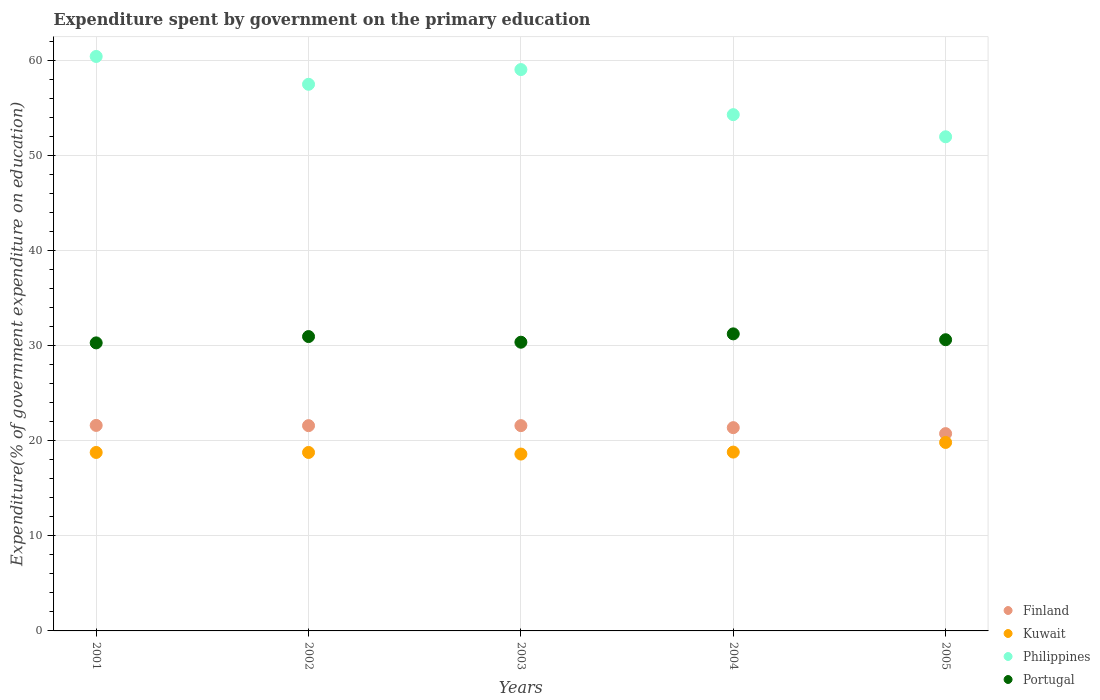What is the expenditure spent by government on the primary education in Kuwait in 2002?
Give a very brief answer. 18.78. Across all years, what is the maximum expenditure spent by government on the primary education in Kuwait?
Ensure brevity in your answer.  19.83. Across all years, what is the minimum expenditure spent by government on the primary education in Philippines?
Provide a succinct answer. 51.99. In which year was the expenditure spent by government on the primary education in Kuwait maximum?
Provide a succinct answer. 2005. What is the total expenditure spent by government on the primary education in Portugal in the graph?
Your answer should be compact. 153.56. What is the difference between the expenditure spent by government on the primary education in Portugal in 2002 and that in 2003?
Your answer should be compact. 0.59. What is the difference between the expenditure spent by government on the primary education in Philippines in 2005 and the expenditure spent by government on the primary education in Portugal in 2001?
Give a very brief answer. 21.69. What is the average expenditure spent by government on the primary education in Portugal per year?
Your answer should be compact. 30.71. In the year 2001, what is the difference between the expenditure spent by government on the primary education in Kuwait and expenditure spent by government on the primary education in Philippines?
Offer a terse response. -41.67. In how many years, is the expenditure spent by government on the primary education in Kuwait greater than 14 %?
Offer a very short reply. 5. What is the ratio of the expenditure spent by government on the primary education in Philippines in 2004 to that in 2005?
Offer a terse response. 1.04. Is the expenditure spent by government on the primary education in Kuwait in 2002 less than that in 2005?
Provide a short and direct response. Yes. Is the difference between the expenditure spent by government on the primary education in Kuwait in 2003 and 2004 greater than the difference between the expenditure spent by government on the primary education in Philippines in 2003 and 2004?
Ensure brevity in your answer.  No. What is the difference between the highest and the second highest expenditure spent by government on the primary education in Philippines?
Keep it short and to the point. 1.38. What is the difference between the highest and the lowest expenditure spent by government on the primary education in Finland?
Provide a short and direct response. 0.86. Is the sum of the expenditure spent by government on the primary education in Portugal in 2002 and 2004 greater than the maximum expenditure spent by government on the primary education in Finland across all years?
Keep it short and to the point. Yes. Is it the case that in every year, the sum of the expenditure spent by government on the primary education in Philippines and expenditure spent by government on the primary education in Finland  is greater than the sum of expenditure spent by government on the primary education in Kuwait and expenditure spent by government on the primary education in Portugal?
Give a very brief answer. No. How many dotlines are there?
Ensure brevity in your answer.  4. Are the values on the major ticks of Y-axis written in scientific E-notation?
Your answer should be very brief. No. Does the graph contain grids?
Provide a succinct answer. Yes. How many legend labels are there?
Your response must be concise. 4. How are the legend labels stacked?
Make the answer very short. Vertical. What is the title of the graph?
Provide a short and direct response. Expenditure spent by government on the primary education. What is the label or title of the Y-axis?
Offer a very short reply. Expenditure(% of government expenditure on education). What is the Expenditure(% of government expenditure on education) in Finland in 2001?
Provide a short and direct response. 21.62. What is the Expenditure(% of government expenditure on education) of Kuwait in 2001?
Give a very brief answer. 18.78. What is the Expenditure(% of government expenditure on education) in Philippines in 2001?
Provide a short and direct response. 60.45. What is the Expenditure(% of government expenditure on education) of Portugal in 2001?
Keep it short and to the point. 30.31. What is the Expenditure(% of government expenditure on education) of Finland in 2002?
Your answer should be very brief. 21.6. What is the Expenditure(% of government expenditure on education) in Kuwait in 2002?
Make the answer very short. 18.78. What is the Expenditure(% of government expenditure on education) in Philippines in 2002?
Provide a succinct answer. 57.52. What is the Expenditure(% of government expenditure on education) of Portugal in 2002?
Your response must be concise. 30.97. What is the Expenditure(% of government expenditure on education) in Finland in 2003?
Provide a short and direct response. 21.6. What is the Expenditure(% of government expenditure on education) of Kuwait in 2003?
Offer a very short reply. 18.61. What is the Expenditure(% of government expenditure on education) in Philippines in 2003?
Provide a succinct answer. 59.07. What is the Expenditure(% of government expenditure on education) of Portugal in 2003?
Provide a succinct answer. 30.38. What is the Expenditure(% of government expenditure on education) in Finland in 2004?
Your response must be concise. 21.39. What is the Expenditure(% of government expenditure on education) of Kuwait in 2004?
Offer a terse response. 18.82. What is the Expenditure(% of government expenditure on education) in Philippines in 2004?
Keep it short and to the point. 54.32. What is the Expenditure(% of government expenditure on education) in Portugal in 2004?
Your response must be concise. 31.26. What is the Expenditure(% of government expenditure on education) of Finland in 2005?
Your answer should be compact. 20.76. What is the Expenditure(% of government expenditure on education) in Kuwait in 2005?
Your response must be concise. 19.83. What is the Expenditure(% of government expenditure on education) of Philippines in 2005?
Offer a terse response. 51.99. What is the Expenditure(% of government expenditure on education) in Portugal in 2005?
Keep it short and to the point. 30.64. Across all years, what is the maximum Expenditure(% of government expenditure on education) in Finland?
Provide a succinct answer. 21.62. Across all years, what is the maximum Expenditure(% of government expenditure on education) in Kuwait?
Offer a terse response. 19.83. Across all years, what is the maximum Expenditure(% of government expenditure on education) of Philippines?
Your answer should be very brief. 60.45. Across all years, what is the maximum Expenditure(% of government expenditure on education) of Portugal?
Offer a very short reply. 31.26. Across all years, what is the minimum Expenditure(% of government expenditure on education) of Finland?
Provide a short and direct response. 20.76. Across all years, what is the minimum Expenditure(% of government expenditure on education) in Kuwait?
Ensure brevity in your answer.  18.61. Across all years, what is the minimum Expenditure(% of government expenditure on education) in Philippines?
Your answer should be very brief. 51.99. Across all years, what is the minimum Expenditure(% of government expenditure on education) of Portugal?
Provide a succinct answer. 30.31. What is the total Expenditure(% of government expenditure on education) in Finland in the graph?
Ensure brevity in your answer.  106.97. What is the total Expenditure(% of government expenditure on education) in Kuwait in the graph?
Provide a succinct answer. 94.81. What is the total Expenditure(% of government expenditure on education) in Philippines in the graph?
Your answer should be very brief. 283.35. What is the total Expenditure(% of government expenditure on education) in Portugal in the graph?
Your answer should be very brief. 153.56. What is the difference between the Expenditure(% of government expenditure on education) in Finland in 2001 and that in 2002?
Offer a terse response. 0.03. What is the difference between the Expenditure(% of government expenditure on education) in Kuwait in 2001 and that in 2002?
Give a very brief answer. 0. What is the difference between the Expenditure(% of government expenditure on education) in Philippines in 2001 and that in 2002?
Keep it short and to the point. 2.93. What is the difference between the Expenditure(% of government expenditure on education) in Portugal in 2001 and that in 2002?
Provide a succinct answer. -0.66. What is the difference between the Expenditure(% of government expenditure on education) in Finland in 2001 and that in 2003?
Provide a short and direct response. 0.02. What is the difference between the Expenditure(% of government expenditure on education) in Kuwait in 2001 and that in 2003?
Make the answer very short. 0.17. What is the difference between the Expenditure(% of government expenditure on education) in Philippines in 2001 and that in 2003?
Make the answer very short. 1.38. What is the difference between the Expenditure(% of government expenditure on education) of Portugal in 2001 and that in 2003?
Your answer should be compact. -0.07. What is the difference between the Expenditure(% of government expenditure on education) in Finland in 2001 and that in 2004?
Your answer should be very brief. 0.24. What is the difference between the Expenditure(% of government expenditure on education) in Kuwait in 2001 and that in 2004?
Your response must be concise. -0.04. What is the difference between the Expenditure(% of government expenditure on education) of Philippines in 2001 and that in 2004?
Give a very brief answer. 6.12. What is the difference between the Expenditure(% of government expenditure on education) in Portugal in 2001 and that in 2004?
Make the answer very short. -0.95. What is the difference between the Expenditure(% of government expenditure on education) of Finland in 2001 and that in 2005?
Your response must be concise. 0.86. What is the difference between the Expenditure(% of government expenditure on education) in Kuwait in 2001 and that in 2005?
Keep it short and to the point. -1.05. What is the difference between the Expenditure(% of government expenditure on education) of Philippines in 2001 and that in 2005?
Provide a succinct answer. 8.45. What is the difference between the Expenditure(% of government expenditure on education) of Portugal in 2001 and that in 2005?
Provide a succinct answer. -0.33. What is the difference between the Expenditure(% of government expenditure on education) of Finland in 2002 and that in 2003?
Keep it short and to the point. -0. What is the difference between the Expenditure(% of government expenditure on education) in Kuwait in 2002 and that in 2003?
Your answer should be compact. 0.17. What is the difference between the Expenditure(% of government expenditure on education) in Philippines in 2002 and that in 2003?
Your answer should be compact. -1.55. What is the difference between the Expenditure(% of government expenditure on education) in Portugal in 2002 and that in 2003?
Offer a very short reply. 0.59. What is the difference between the Expenditure(% of government expenditure on education) in Finland in 2002 and that in 2004?
Ensure brevity in your answer.  0.21. What is the difference between the Expenditure(% of government expenditure on education) in Kuwait in 2002 and that in 2004?
Ensure brevity in your answer.  -0.04. What is the difference between the Expenditure(% of government expenditure on education) in Philippines in 2002 and that in 2004?
Provide a succinct answer. 3.2. What is the difference between the Expenditure(% of government expenditure on education) of Portugal in 2002 and that in 2004?
Ensure brevity in your answer.  -0.28. What is the difference between the Expenditure(% of government expenditure on education) of Finland in 2002 and that in 2005?
Provide a succinct answer. 0.84. What is the difference between the Expenditure(% of government expenditure on education) of Kuwait in 2002 and that in 2005?
Offer a terse response. -1.05. What is the difference between the Expenditure(% of government expenditure on education) in Philippines in 2002 and that in 2005?
Your answer should be very brief. 5.52. What is the difference between the Expenditure(% of government expenditure on education) of Portugal in 2002 and that in 2005?
Offer a terse response. 0.33. What is the difference between the Expenditure(% of government expenditure on education) in Finland in 2003 and that in 2004?
Provide a short and direct response. 0.21. What is the difference between the Expenditure(% of government expenditure on education) in Kuwait in 2003 and that in 2004?
Keep it short and to the point. -0.21. What is the difference between the Expenditure(% of government expenditure on education) in Philippines in 2003 and that in 2004?
Offer a very short reply. 4.74. What is the difference between the Expenditure(% of government expenditure on education) in Portugal in 2003 and that in 2004?
Provide a succinct answer. -0.88. What is the difference between the Expenditure(% of government expenditure on education) of Finland in 2003 and that in 2005?
Make the answer very short. 0.84. What is the difference between the Expenditure(% of government expenditure on education) in Kuwait in 2003 and that in 2005?
Your answer should be very brief. -1.22. What is the difference between the Expenditure(% of government expenditure on education) of Philippines in 2003 and that in 2005?
Offer a very short reply. 7.07. What is the difference between the Expenditure(% of government expenditure on education) in Portugal in 2003 and that in 2005?
Make the answer very short. -0.26. What is the difference between the Expenditure(% of government expenditure on education) in Finland in 2004 and that in 2005?
Ensure brevity in your answer.  0.63. What is the difference between the Expenditure(% of government expenditure on education) of Kuwait in 2004 and that in 2005?
Provide a short and direct response. -1.01. What is the difference between the Expenditure(% of government expenditure on education) of Philippines in 2004 and that in 2005?
Your response must be concise. 2.33. What is the difference between the Expenditure(% of government expenditure on education) of Portugal in 2004 and that in 2005?
Make the answer very short. 0.62. What is the difference between the Expenditure(% of government expenditure on education) of Finland in 2001 and the Expenditure(% of government expenditure on education) of Kuwait in 2002?
Provide a succinct answer. 2.85. What is the difference between the Expenditure(% of government expenditure on education) of Finland in 2001 and the Expenditure(% of government expenditure on education) of Philippines in 2002?
Provide a succinct answer. -35.89. What is the difference between the Expenditure(% of government expenditure on education) in Finland in 2001 and the Expenditure(% of government expenditure on education) in Portugal in 2002?
Your answer should be very brief. -9.35. What is the difference between the Expenditure(% of government expenditure on education) of Kuwait in 2001 and the Expenditure(% of government expenditure on education) of Philippines in 2002?
Your answer should be compact. -38.74. What is the difference between the Expenditure(% of government expenditure on education) in Kuwait in 2001 and the Expenditure(% of government expenditure on education) in Portugal in 2002?
Keep it short and to the point. -12.19. What is the difference between the Expenditure(% of government expenditure on education) of Philippines in 2001 and the Expenditure(% of government expenditure on education) of Portugal in 2002?
Provide a short and direct response. 29.47. What is the difference between the Expenditure(% of government expenditure on education) of Finland in 2001 and the Expenditure(% of government expenditure on education) of Kuwait in 2003?
Offer a very short reply. 3.02. What is the difference between the Expenditure(% of government expenditure on education) in Finland in 2001 and the Expenditure(% of government expenditure on education) in Philippines in 2003?
Offer a terse response. -37.44. What is the difference between the Expenditure(% of government expenditure on education) in Finland in 2001 and the Expenditure(% of government expenditure on education) in Portugal in 2003?
Your response must be concise. -8.75. What is the difference between the Expenditure(% of government expenditure on education) in Kuwait in 2001 and the Expenditure(% of government expenditure on education) in Philippines in 2003?
Offer a very short reply. -40.29. What is the difference between the Expenditure(% of government expenditure on education) in Kuwait in 2001 and the Expenditure(% of government expenditure on education) in Portugal in 2003?
Keep it short and to the point. -11.6. What is the difference between the Expenditure(% of government expenditure on education) of Philippines in 2001 and the Expenditure(% of government expenditure on education) of Portugal in 2003?
Your response must be concise. 30.07. What is the difference between the Expenditure(% of government expenditure on education) of Finland in 2001 and the Expenditure(% of government expenditure on education) of Kuwait in 2004?
Your answer should be very brief. 2.81. What is the difference between the Expenditure(% of government expenditure on education) of Finland in 2001 and the Expenditure(% of government expenditure on education) of Philippines in 2004?
Make the answer very short. -32.7. What is the difference between the Expenditure(% of government expenditure on education) of Finland in 2001 and the Expenditure(% of government expenditure on education) of Portugal in 2004?
Provide a short and direct response. -9.63. What is the difference between the Expenditure(% of government expenditure on education) in Kuwait in 2001 and the Expenditure(% of government expenditure on education) in Philippines in 2004?
Make the answer very short. -35.54. What is the difference between the Expenditure(% of government expenditure on education) of Kuwait in 2001 and the Expenditure(% of government expenditure on education) of Portugal in 2004?
Offer a terse response. -12.48. What is the difference between the Expenditure(% of government expenditure on education) of Philippines in 2001 and the Expenditure(% of government expenditure on education) of Portugal in 2004?
Your answer should be very brief. 29.19. What is the difference between the Expenditure(% of government expenditure on education) of Finland in 2001 and the Expenditure(% of government expenditure on education) of Kuwait in 2005?
Your answer should be compact. 1.79. What is the difference between the Expenditure(% of government expenditure on education) in Finland in 2001 and the Expenditure(% of government expenditure on education) in Philippines in 2005?
Your answer should be compact. -30.37. What is the difference between the Expenditure(% of government expenditure on education) in Finland in 2001 and the Expenditure(% of government expenditure on education) in Portugal in 2005?
Your response must be concise. -9.02. What is the difference between the Expenditure(% of government expenditure on education) of Kuwait in 2001 and the Expenditure(% of government expenditure on education) of Philippines in 2005?
Provide a short and direct response. -33.22. What is the difference between the Expenditure(% of government expenditure on education) in Kuwait in 2001 and the Expenditure(% of government expenditure on education) in Portugal in 2005?
Your answer should be very brief. -11.86. What is the difference between the Expenditure(% of government expenditure on education) in Philippines in 2001 and the Expenditure(% of government expenditure on education) in Portugal in 2005?
Give a very brief answer. 29.81. What is the difference between the Expenditure(% of government expenditure on education) in Finland in 2002 and the Expenditure(% of government expenditure on education) in Kuwait in 2003?
Keep it short and to the point. 2.99. What is the difference between the Expenditure(% of government expenditure on education) in Finland in 2002 and the Expenditure(% of government expenditure on education) in Philippines in 2003?
Offer a very short reply. -37.47. What is the difference between the Expenditure(% of government expenditure on education) of Finland in 2002 and the Expenditure(% of government expenditure on education) of Portugal in 2003?
Your response must be concise. -8.78. What is the difference between the Expenditure(% of government expenditure on education) in Kuwait in 2002 and the Expenditure(% of government expenditure on education) in Philippines in 2003?
Provide a short and direct response. -40.29. What is the difference between the Expenditure(% of government expenditure on education) in Kuwait in 2002 and the Expenditure(% of government expenditure on education) in Portugal in 2003?
Keep it short and to the point. -11.6. What is the difference between the Expenditure(% of government expenditure on education) in Philippines in 2002 and the Expenditure(% of government expenditure on education) in Portugal in 2003?
Ensure brevity in your answer.  27.14. What is the difference between the Expenditure(% of government expenditure on education) in Finland in 2002 and the Expenditure(% of government expenditure on education) in Kuwait in 2004?
Make the answer very short. 2.78. What is the difference between the Expenditure(% of government expenditure on education) in Finland in 2002 and the Expenditure(% of government expenditure on education) in Philippines in 2004?
Keep it short and to the point. -32.72. What is the difference between the Expenditure(% of government expenditure on education) in Finland in 2002 and the Expenditure(% of government expenditure on education) in Portugal in 2004?
Offer a very short reply. -9.66. What is the difference between the Expenditure(% of government expenditure on education) of Kuwait in 2002 and the Expenditure(% of government expenditure on education) of Philippines in 2004?
Keep it short and to the point. -35.54. What is the difference between the Expenditure(% of government expenditure on education) of Kuwait in 2002 and the Expenditure(% of government expenditure on education) of Portugal in 2004?
Provide a short and direct response. -12.48. What is the difference between the Expenditure(% of government expenditure on education) in Philippines in 2002 and the Expenditure(% of government expenditure on education) in Portugal in 2004?
Offer a terse response. 26.26. What is the difference between the Expenditure(% of government expenditure on education) of Finland in 2002 and the Expenditure(% of government expenditure on education) of Kuwait in 2005?
Offer a terse response. 1.77. What is the difference between the Expenditure(% of government expenditure on education) in Finland in 2002 and the Expenditure(% of government expenditure on education) in Philippines in 2005?
Keep it short and to the point. -30.39. What is the difference between the Expenditure(% of government expenditure on education) of Finland in 2002 and the Expenditure(% of government expenditure on education) of Portugal in 2005?
Give a very brief answer. -9.04. What is the difference between the Expenditure(% of government expenditure on education) of Kuwait in 2002 and the Expenditure(% of government expenditure on education) of Philippines in 2005?
Your answer should be very brief. -33.22. What is the difference between the Expenditure(% of government expenditure on education) of Kuwait in 2002 and the Expenditure(% of government expenditure on education) of Portugal in 2005?
Ensure brevity in your answer.  -11.86. What is the difference between the Expenditure(% of government expenditure on education) in Philippines in 2002 and the Expenditure(% of government expenditure on education) in Portugal in 2005?
Ensure brevity in your answer.  26.88. What is the difference between the Expenditure(% of government expenditure on education) of Finland in 2003 and the Expenditure(% of government expenditure on education) of Kuwait in 2004?
Give a very brief answer. 2.78. What is the difference between the Expenditure(% of government expenditure on education) of Finland in 2003 and the Expenditure(% of government expenditure on education) of Philippines in 2004?
Your response must be concise. -32.72. What is the difference between the Expenditure(% of government expenditure on education) of Finland in 2003 and the Expenditure(% of government expenditure on education) of Portugal in 2004?
Your answer should be very brief. -9.66. What is the difference between the Expenditure(% of government expenditure on education) of Kuwait in 2003 and the Expenditure(% of government expenditure on education) of Philippines in 2004?
Provide a succinct answer. -35.71. What is the difference between the Expenditure(% of government expenditure on education) in Kuwait in 2003 and the Expenditure(% of government expenditure on education) in Portugal in 2004?
Ensure brevity in your answer.  -12.65. What is the difference between the Expenditure(% of government expenditure on education) in Philippines in 2003 and the Expenditure(% of government expenditure on education) in Portugal in 2004?
Provide a short and direct response. 27.81. What is the difference between the Expenditure(% of government expenditure on education) of Finland in 2003 and the Expenditure(% of government expenditure on education) of Kuwait in 2005?
Your answer should be compact. 1.77. What is the difference between the Expenditure(% of government expenditure on education) in Finland in 2003 and the Expenditure(% of government expenditure on education) in Philippines in 2005?
Provide a succinct answer. -30.39. What is the difference between the Expenditure(% of government expenditure on education) in Finland in 2003 and the Expenditure(% of government expenditure on education) in Portugal in 2005?
Offer a terse response. -9.04. What is the difference between the Expenditure(% of government expenditure on education) in Kuwait in 2003 and the Expenditure(% of government expenditure on education) in Philippines in 2005?
Offer a very short reply. -33.39. What is the difference between the Expenditure(% of government expenditure on education) of Kuwait in 2003 and the Expenditure(% of government expenditure on education) of Portugal in 2005?
Ensure brevity in your answer.  -12.03. What is the difference between the Expenditure(% of government expenditure on education) of Philippines in 2003 and the Expenditure(% of government expenditure on education) of Portugal in 2005?
Your response must be concise. 28.43. What is the difference between the Expenditure(% of government expenditure on education) of Finland in 2004 and the Expenditure(% of government expenditure on education) of Kuwait in 2005?
Provide a short and direct response. 1.56. What is the difference between the Expenditure(% of government expenditure on education) of Finland in 2004 and the Expenditure(% of government expenditure on education) of Philippines in 2005?
Give a very brief answer. -30.61. What is the difference between the Expenditure(% of government expenditure on education) of Finland in 2004 and the Expenditure(% of government expenditure on education) of Portugal in 2005?
Make the answer very short. -9.25. What is the difference between the Expenditure(% of government expenditure on education) of Kuwait in 2004 and the Expenditure(% of government expenditure on education) of Philippines in 2005?
Make the answer very short. -33.18. What is the difference between the Expenditure(% of government expenditure on education) in Kuwait in 2004 and the Expenditure(% of government expenditure on education) in Portugal in 2005?
Provide a short and direct response. -11.82. What is the difference between the Expenditure(% of government expenditure on education) of Philippines in 2004 and the Expenditure(% of government expenditure on education) of Portugal in 2005?
Provide a succinct answer. 23.68. What is the average Expenditure(% of government expenditure on education) of Finland per year?
Make the answer very short. 21.39. What is the average Expenditure(% of government expenditure on education) in Kuwait per year?
Make the answer very short. 18.96. What is the average Expenditure(% of government expenditure on education) of Philippines per year?
Offer a terse response. 56.67. What is the average Expenditure(% of government expenditure on education) in Portugal per year?
Keep it short and to the point. 30.71. In the year 2001, what is the difference between the Expenditure(% of government expenditure on education) in Finland and Expenditure(% of government expenditure on education) in Kuwait?
Give a very brief answer. 2.85. In the year 2001, what is the difference between the Expenditure(% of government expenditure on education) in Finland and Expenditure(% of government expenditure on education) in Philippines?
Offer a terse response. -38.82. In the year 2001, what is the difference between the Expenditure(% of government expenditure on education) of Finland and Expenditure(% of government expenditure on education) of Portugal?
Keep it short and to the point. -8.68. In the year 2001, what is the difference between the Expenditure(% of government expenditure on education) of Kuwait and Expenditure(% of government expenditure on education) of Philippines?
Make the answer very short. -41.67. In the year 2001, what is the difference between the Expenditure(% of government expenditure on education) in Kuwait and Expenditure(% of government expenditure on education) in Portugal?
Keep it short and to the point. -11.53. In the year 2001, what is the difference between the Expenditure(% of government expenditure on education) of Philippines and Expenditure(% of government expenditure on education) of Portugal?
Provide a succinct answer. 30.14. In the year 2002, what is the difference between the Expenditure(% of government expenditure on education) in Finland and Expenditure(% of government expenditure on education) in Kuwait?
Keep it short and to the point. 2.82. In the year 2002, what is the difference between the Expenditure(% of government expenditure on education) of Finland and Expenditure(% of government expenditure on education) of Philippines?
Keep it short and to the point. -35.92. In the year 2002, what is the difference between the Expenditure(% of government expenditure on education) in Finland and Expenditure(% of government expenditure on education) in Portugal?
Keep it short and to the point. -9.37. In the year 2002, what is the difference between the Expenditure(% of government expenditure on education) of Kuwait and Expenditure(% of government expenditure on education) of Philippines?
Give a very brief answer. -38.74. In the year 2002, what is the difference between the Expenditure(% of government expenditure on education) of Kuwait and Expenditure(% of government expenditure on education) of Portugal?
Give a very brief answer. -12.19. In the year 2002, what is the difference between the Expenditure(% of government expenditure on education) in Philippines and Expenditure(% of government expenditure on education) in Portugal?
Give a very brief answer. 26.55. In the year 2003, what is the difference between the Expenditure(% of government expenditure on education) of Finland and Expenditure(% of government expenditure on education) of Kuwait?
Provide a short and direct response. 2.99. In the year 2003, what is the difference between the Expenditure(% of government expenditure on education) in Finland and Expenditure(% of government expenditure on education) in Philippines?
Keep it short and to the point. -37.47. In the year 2003, what is the difference between the Expenditure(% of government expenditure on education) of Finland and Expenditure(% of government expenditure on education) of Portugal?
Provide a short and direct response. -8.78. In the year 2003, what is the difference between the Expenditure(% of government expenditure on education) of Kuwait and Expenditure(% of government expenditure on education) of Philippines?
Your answer should be compact. -40.46. In the year 2003, what is the difference between the Expenditure(% of government expenditure on education) in Kuwait and Expenditure(% of government expenditure on education) in Portugal?
Provide a short and direct response. -11.77. In the year 2003, what is the difference between the Expenditure(% of government expenditure on education) of Philippines and Expenditure(% of government expenditure on education) of Portugal?
Give a very brief answer. 28.69. In the year 2004, what is the difference between the Expenditure(% of government expenditure on education) in Finland and Expenditure(% of government expenditure on education) in Kuwait?
Your answer should be compact. 2.57. In the year 2004, what is the difference between the Expenditure(% of government expenditure on education) in Finland and Expenditure(% of government expenditure on education) in Philippines?
Make the answer very short. -32.93. In the year 2004, what is the difference between the Expenditure(% of government expenditure on education) of Finland and Expenditure(% of government expenditure on education) of Portugal?
Your answer should be compact. -9.87. In the year 2004, what is the difference between the Expenditure(% of government expenditure on education) in Kuwait and Expenditure(% of government expenditure on education) in Philippines?
Your answer should be very brief. -35.51. In the year 2004, what is the difference between the Expenditure(% of government expenditure on education) of Kuwait and Expenditure(% of government expenditure on education) of Portugal?
Your response must be concise. -12.44. In the year 2004, what is the difference between the Expenditure(% of government expenditure on education) in Philippines and Expenditure(% of government expenditure on education) in Portugal?
Give a very brief answer. 23.07. In the year 2005, what is the difference between the Expenditure(% of government expenditure on education) in Finland and Expenditure(% of government expenditure on education) in Kuwait?
Offer a terse response. 0.93. In the year 2005, what is the difference between the Expenditure(% of government expenditure on education) of Finland and Expenditure(% of government expenditure on education) of Philippines?
Make the answer very short. -31.23. In the year 2005, what is the difference between the Expenditure(% of government expenditure on education) of Finland and Expenditure(% of government expenditure on education) of Portugal?
Provide a short and direct response. -9.88. In the year 2005, what is the difference between the Expenditure(% of government expenditure on education) in Kuwait and Expenditure(% of government expenditure on education) in Philippines?
Provide a succinct answer. -32.16. In the year 2005, what is the difference between the Expenditure(% of government expenditure on education) of Kuwait and Expenditure(% of government expenditure on education) of Portugal?
Provide a short and direct response. -10.81. In the year 2005, what is the difference between the Expenditure(% of government expenditure on education) in Philippines and Expenditure(% of government expenditure on education) in Portugal?
Ensure brevity in your answer.  21.35. What is the ratio of the Expenditure(% of government expenditure on education) of Finland in 2001 to that in 2002?
Give a very brief answer. 1. What is the ratio of the Expenditure(% of government expenditure on education) of Kuwait in 2001 to that in 2002?
Keep it short and to the point. 1. What is the ratio of the Expenditure(% of government expenditure on education) in Philippines in 2001 to that in 2002?
Provide a short and direct response. 1.05. What is the ratio of the Expenditure(% of government expenditure on education) of Portugal in 2001 to that in 2002?
Offer a very short reply. 0.98. What is the ratio of the Expenditure(% of government expenditure on education) in Kuwait in 2001 to that in 2003?
Keep it short and to the point. 1.01. What is the ratio of the Expenditure(% of government expenditure on education) in Philippines in 2001 to that in 2003?
Your response must be concise. 1.02. What is the ratio of the Expenditure(% of government expenditure on education) in Portugal in 2001 to that in 2003?
Your response must be concise. 1. What is the ratio of the Expenditure(% of government expenditure on education) of Finland in 2001 to that in 2004?
Provide a succinct answer. 1.01. What is the ratio of the Expenditure(% of government expenditure on education) of Philippines in 2001 to that in 2004?
Make the answer very short. 1.11. What is the ratio of the Expenditure(% of government expenditure on education) of Portugal in 2001 to that in 2004?
Ensure brevity in your answer.  0.97. What is the ratio of the Expenditure(% of government expenditure on education) in Finland in 2001 to that in 2005?
Provide a succinct answer. 1.04. What is the ratio of the Expenditure(% of government expenditure on education) in Kuwait in 2001 to that in 2005?
Make the answer very short. 0.95. What is the ratio of the Expenditure(% of government expenditure on education) of Philippines in 2001 to that in 2005?
Your answer should be compact. 1.16. What is the ratio of the Expenditure(% of government expenditure on education) of Portugal in 2001 to that in 2005?
Your answer should be very brief. 0.99. What is the ratio of the Expenditure(% of government expenditure on education) of Kuwait in 2002 to that in 2003?
Your answer should be very brief. 1.01. What is the ratio of the Expenditure(% of government expenditure on education) of Philippines in 2002 to that in 2003?
Give a very brief answer. 0.97. What is the ratio of the Expenditure(% of government expenditure on education) in Portugal in 2002 to that in 2003?
Offer a terse response. 1.02. What is the ratio of the Expenditure(% of government expenditure on education) of Finland in 2002 to that in 2004?
Ensure brevity in your answer.  1.01. What is the ratio of the Expenditure(% of government expenditure on education) in Philippines in 2002 to that in 2004?
Make the answer very short. 1.06. What is the ratio of the Expenditure(% of government expenditure on education) in Portugal in 2002 to that in 2004?
Your answer should be very brief. 0.99. What is the ratio of the Expenditure(% of government expenditure on education) of Finland in 2002 to that in 2005?
Your answer should be compact. 1.04. What is the ratio of the Expenditure(% of government expenditure on education) in Kuwait in 2002 to that in 2005?
Provide a short and direct response. 0.95. What is the ratio of the Expenditure(% of government expenditure on education) in Philippines in 2002 to that in 2005?
Your response must be concise. 1.11. What is the ratio of the Expenditure(% of government expenditure on education) in Portugal in 2002 to that in 2005?
Make the answer very short. 1.01. What is the ratio of the Expenditure(% of government expenditure on education) in Finland in 2003 to that in 2004?
Give a very brief answer. 1.01. What is the ratio of the Expenditure(% of government expenditure on education) in Kuwait in 2003 to that in 2004?
Keep it short and to the point. 0.99. What is the ratio of the Expenditure(% of government expenditure on education) in Philippines in 2003 to that in 2004?
Your response must be concise. 1.09. What is the ratio of the Expenditure(% of government expenditure on education) of Portugal in 2003 to that in 2004?
Provide a short and direct response. 0.97. What is the ratio of the Expenditure(% of government expenditure on education) of Finland in 2003 to that in 2005?
Your response must be concise. 1.04. What is the ratio of the Expenditure(% of government expenditure on education) of Kuwait in 2003 to that in 2005?
Make the answer very short. 0.94. What is the ratio of the Expenditure(% of government expenditure on education) of Philippines in 2003 to that in 2005?
Provide a succinct answer. 1.14. What is the ratio of the Expenditure(% of government expenditure on education) of Finland in 2004 to that in 2005?
Your answer should be very brief. 1.03. What is the ratio of the Expenditure(% of government expenditure on education) of Kuwait in 2004 to that in 2005?
Give a very brief answer. 0.95. What is the ratio of the Expenditure(% of government expenditure on education) in Philippines in 2004 to that in 2005?
Your response must be concise. 1.04. What is the ratio of the Expenditure(% of government expenditure on education) in Portugal in 2004 to that in 2005?
Provide a short and direct response. 1.02. What is the difference between the highest and the second highest Expenditure(% of government expenditure on education) of Finland?
Offer a very short reply. 0.02. What is the difference between the highest and the second highest Expenditure(% of government expenditure on education) of Kuwait?
Give a very brief answer. 1.01. What is the difference between the highest and the second highest Expenditure(% of government expenditure on education) in Philippines?
Keep it short and to the point. 1.38. What is the difference between the highest and the second highest Expenditure(% of government expenditure on education) of Portugal?
Provide a short and direct response. 0.28. What is the difference between the highest and the lowest Expenditure(% of government expenditure on education) in Finland?
Make the answer very short. 0.86. What is the difference between the highest and the lowest Expenditure(% of government expenditure on education) in Kuwait?
Your answer should be very brief. 1.22. What is the difference between the highest and the lowest Expenditure(% of government expenditure on education) in Philippines?
Give a very brief answer. 8.45. What is the difference between the highest and the lowest Expenditure(% of government expenditure on education) of Portugal?
Your response must be concise. 0.95. 